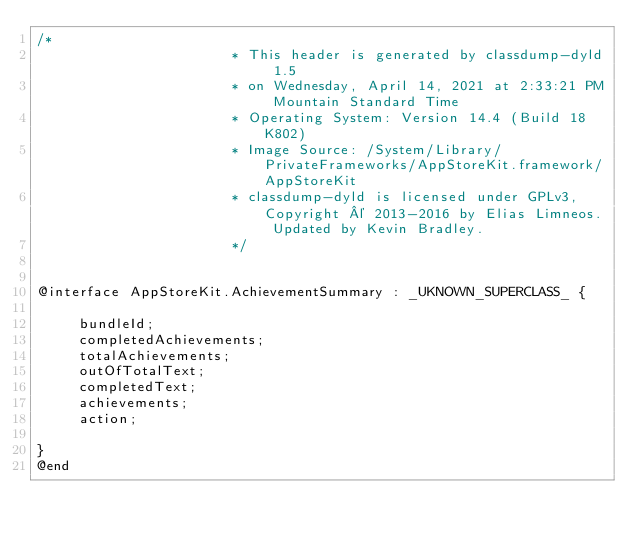<code> <loc_0><loc_0><loc_500><loc_500><_C_>/*
                       * This header is generated by classdump-dyld 1.5
                       * on Wednesday, April 14, 2021 at 2:33:21 PM Mountain Standard Time
                       * Operating System: Version 14.4 (Build 18K802)
                       * Image Source: /System/Library/PrivateFrameworks/AppStoreKit.framework/AppStoreKit
                       * classdump-dyld is licensed under GPLv3, Copyright © 2013-2016 by Elias Limneos. Updated by Kevin Bradley.
                       */


@interface AppStoreKit.AchievementSummary : _UKNOWN_SUPERCLASS_ {

	 bundleId;
	 completedAchievements;
	 totalAchievements;
	 outOfTotalText;
	 completedText;
	 achievements;
	 action;

}
@end

</code> 